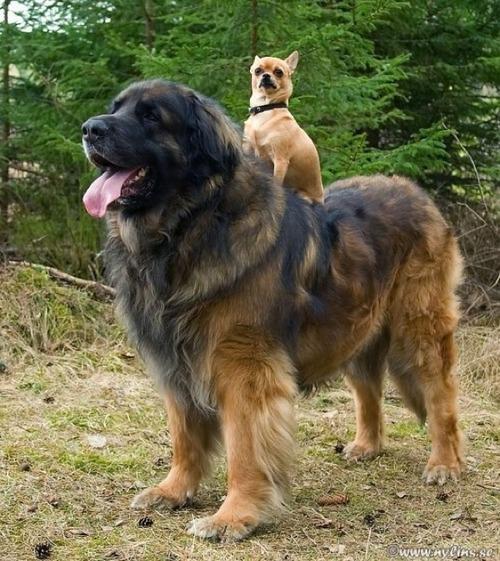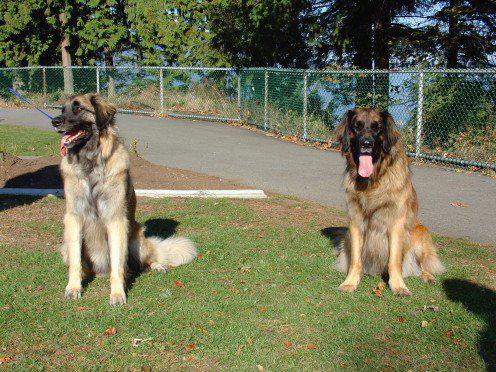The first image is the image on the left, the second image is the image on the right. For the images shown, is this caption "At least one image shows two mammals." true? Answer yes or no. Yes. 